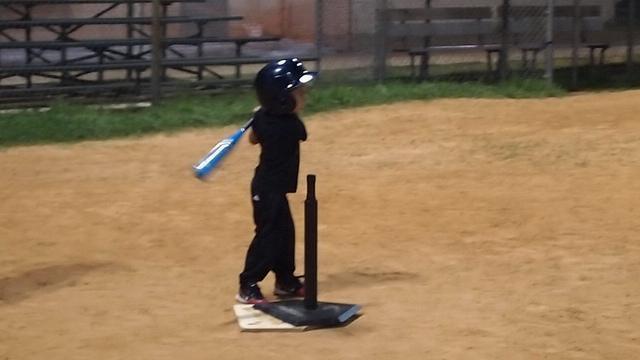Who would the child be more likely to admire?
Make your selection from the four choices given to correctly answer the question.
Options: Pete alonso, pele, wayne gretzky, tiger woods. Pete alonso. 